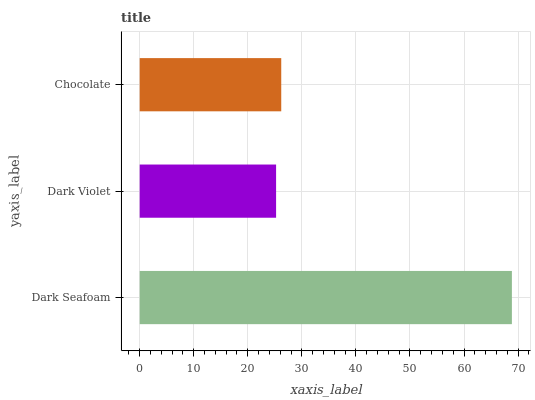Is Dark Violet the minimum?
Answer yes or no. Yes. Is Dark Seafoam the maximum?
Answer yes or no. Yes. Is Chocolate the minimum?
Answer yes or no. No. Is Chocolate the maximum?
Answer yes or no. No. Is Chocolate greater than Dark Violet?
Answer yes or no. Yes. Is Dark Violet less than Chocolate?
Answer yes or no. Yes. Is Dark Violet greater than Chocolate?
Answer yes or no. No. Is Chocolate less than Dark Violet?
Answer yes or no. No. Is Chocolate the high median?
Answer yes or no. Yes. Is Chocolate the low median?
Answer yes or no. Yes. Is Dark Violet the high median?
Answer yes or no. No. Is Dark Seafoam the low median?
Answer yes or no. No. 